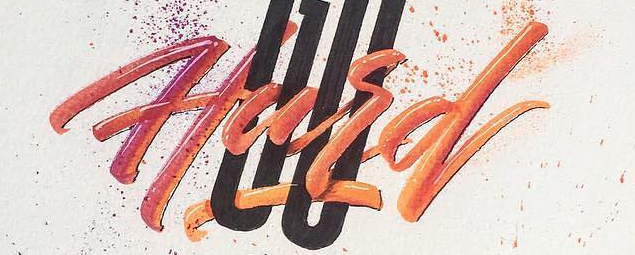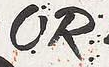Read the text from these images in sequence, separated by a semicolon. Hard; OR 